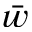<formula> <loc_0><loc_0><loc_500><loc_500>\bar { w }</formula> 